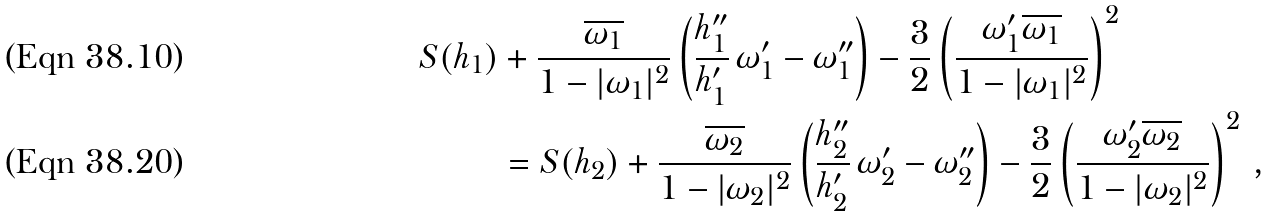Convert formula to latex. <formula><loc_0><loc_0><loc_500><loc_500>S ( h _ { 1 } ) & + \frac { \overline { \omega _ { 1 } } } { 1 - | \omega _ { 1 } | ^ { 2 } } \left ( \frac { h ^ { \prime \prime } _ { 1 } } { h ^ { \prime } _ { 1 } } \, \omega ^ { \prime } _ { 1 } - \omega ^ { \prime \prime } _ { 1 } \right ) - \frac { 3 } { 2 } \left ( \frac { \omega ^ { \prime } _ { 1 } \overline { \omega _ { 1 } } } { 1 - | \omega _ { 1 } | ^ { 2 } } \right ) ^ { 2 } \\ & = S ( h _ { 2 } ) + \frac { \overline { \omega _ { 2 } } } { 1 - | \omega _ { 2 } | ^ { 2 } } \left ( \frac { h ^ { \prime \prime } _ { 2 } } { h ^ { \prime } _ { 2 } } \, \omega ^ { \prime } _ { 2 } - \omega ^ { \prime \prime } _ { 2 } \right ) - \frac { 3 } { 2 } \left ( \frac { \omega ^ { \prime } _ { 2 } \overline { \omega _ { 2 } } } { 1 - | \omega _ { 2 } | ^ { 2 } } \right ) ^ { 2 } \, ,</formula> 